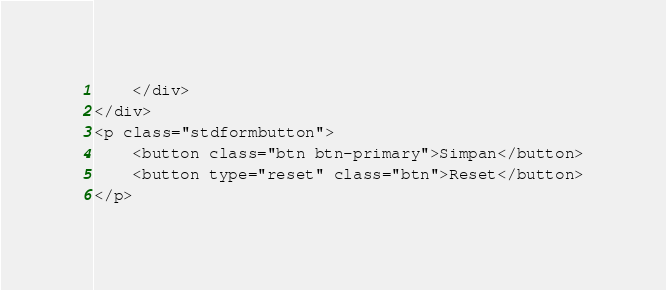<code> <loc_0><loc_0><loc_500><loc_500><_PHP_>    </div>                
</div>
<p class="stdformbutton">
    <button class="btn btn-primary">Simpan</button>
    <button type="reset" class="btn">Reset</button>
</p></code> 